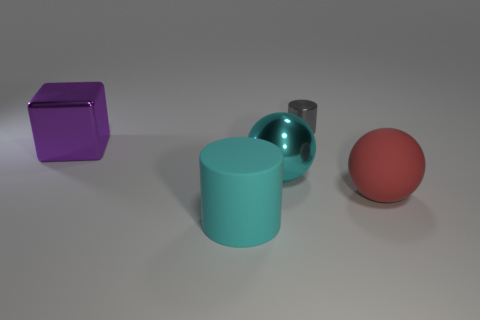Add 3 gray metal blocks. How many objects exist? 8 Subtract all blocks. How many objects are left? 4 Add 5 big rubber spheres. How many big rubber spheres are left? 6 Add 1 matte cylinders. How many matte cylinders exist? 2 Subtract 0 brown cylinders. How many objects are left? 5 Subtract all red balls. Subtract all metal spheres. How many objects are left? 3 